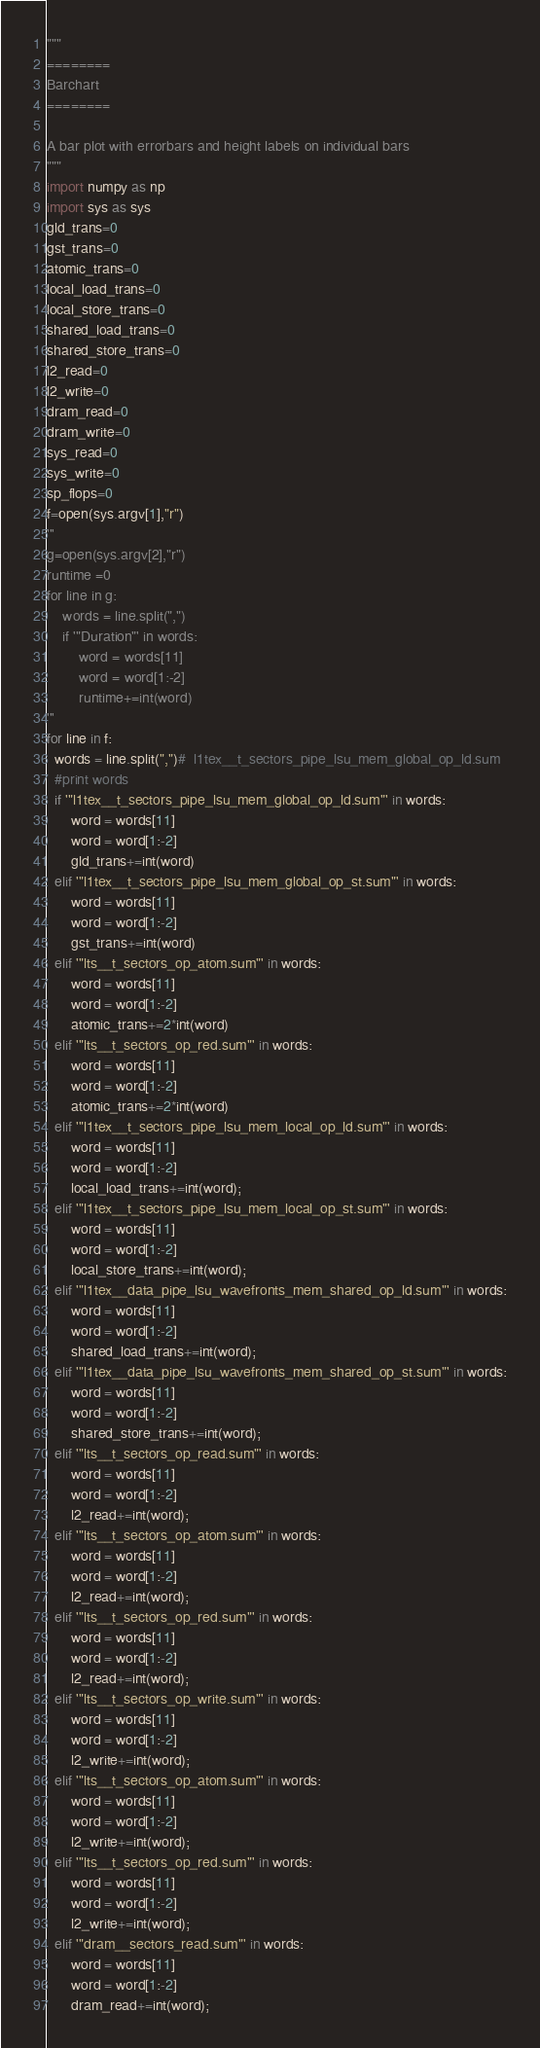Convert code to text. <code><loc_0><loc_0><loc_500><loc_500><_Python_>"""
========
Barchart
========

A bar plot with errorbars and height labels on individual bars
"""
import numpy as np
import sys as sys
gld_trans=0
gst_trans=0
atomic_trans=0
local_load_trans=0
local_store_trans=0
shared_load_trans=0
shared_store_trans=0
l2_read=0
l2_write=0
dram_read=0
dram_write=0
sys_read=0
sys_write=0
sp_flops=0
f=open(sys.argv[1],"r")
'''
g=open(sys.argv[2],"r")
runtime =0
for line in g:
    words = line.split(",")
    if '"Duration"' in words:
        word = words[11]
        word = word[1:-2]
        runtime+=int(word)
'''
for line in f:
  words = line.split(",")#  l1tex__t_sectors_pipe_lsu_mem_global_op_ld.sum
  #print words
  if '"l1tex__t_sectors_pipe_lsu_mem_global_op_ld.sum"' in words:
      word = words[11]
      word = word[1:-2]
      gld_trans+=int(word)
  elif '"l1tex__t_sectors_pipe_lsu_mem_global_op_st.sum"' in words:
      word = words[11]
      word = word[1:-2]
      gst_trans+=int(word)
  elif '"lts__t_sectors_op_atom.sum"' in words:
      word = words[11]
      word = word[1:-2]
      atomic_trans+=2*int(word)
  elif '"lts__t_sectors_op_red.sum"' in words:
      word = words[11]
      word = word[1:-2]
      atomic_trans+=2*int(word)
  elif '"l1tex__t_sectors_pipe_lsu_mem_local_op_ld.sum"' in words:
      word = words[11]
      word = word[1:-2]
      local_load_trans+=int(word);
  elif '"l1tex__t_sectors_pipe_lsu_mem_local_op_st.sum"' in words:
      word = words[11]
      word = word[1:-2]
      local_store_trans+=int(word);
  elif '"l1tex__data_pipe_lsu_wavefronts_mem_shared_op_ld.sum"' in words:
      word = words[11]
      word = word[1:-2]
      shared_load_trans+=int(word);
  elif '"l1tex__data_pipe_lsu_wavefronts_mem_shared_op_st.sum"' in words:
      word = words[11]
      word = word[1:-2]
      shared_store_trans+=int(word);
  elif '"lts__t_sectors_op_read.sum"' in words:
      word = words[11]
      word = word[1:-2]
      l2_read+=int(word);
  elif '"lts__t_sectors_op_atom.sum"' in words:
      word = words[11]
      word = word[1:-2]
      l2_read+=int(word);
  elif '"lts__t_sectors_op_red.sum"' in words:
      word = words[11]
      word = word[1:-2]
      l2_read+=int(word);
  elif '"lts__t_sectors_op_write.sum"' in words:
      word = words[11]
      word = word[1:-2]
      l2_write+=int(word);
  elif '"lts__t_sectors_op_atom.sum"' in words:
      word = words[11]
      word = word[1:-2]
      l2_write+=int(word);
  elif '"lts__t_sectors_op_red.sum"' in words:
      word = words[11]
      word = word[1:-2]
      l2_write+=int(word);
  elif '"dram__sectors_read.sum"' in words:
      word = words[11]
      word = word[1:-2]
      dram_read+=int(word);</code> 